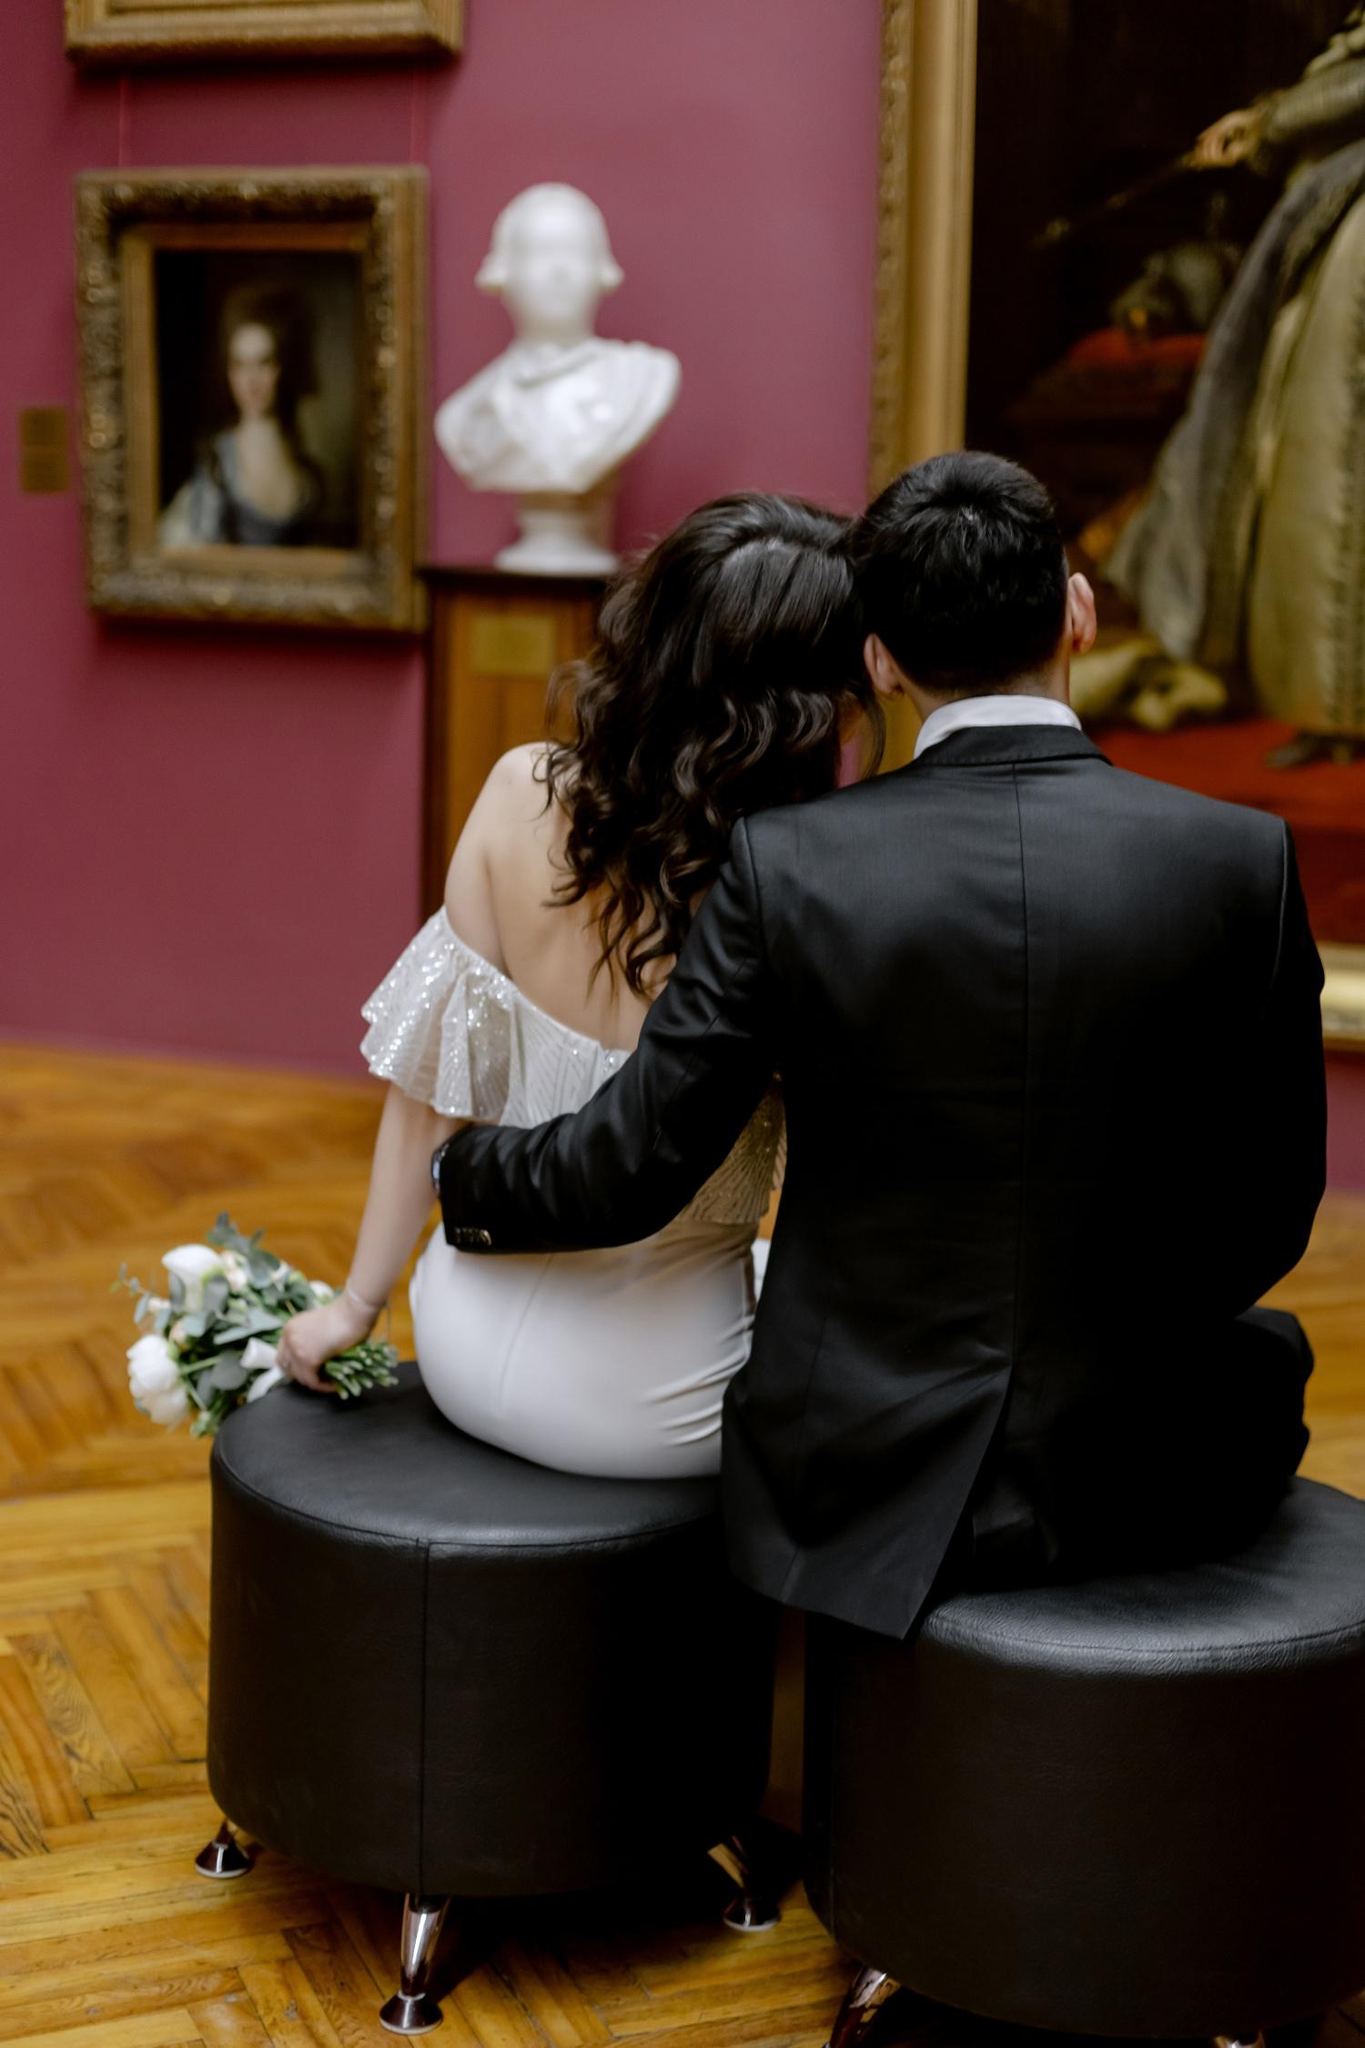Can you tell me more about the artwork they are looking at? The couple appears to be viewing a classical sculpture of a bust, which is positioned on a pedestal. Nearby, there's a painting set in a golden frame, depicting a regal woman dressed in period attire that suggests 18th-century European fashion. The artwork, combined with the ambient architecture and decor, enhances the gallery's elegant and historical ambiance. This setting seems to provide an enriching visual experience for the viewers, steeped in history and artistic grandeur. 